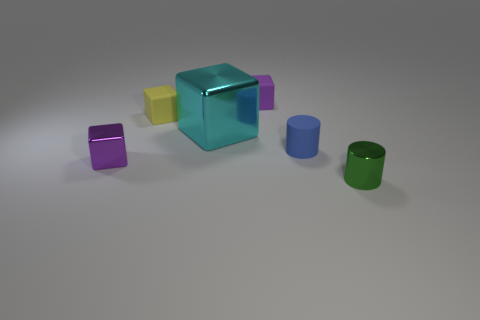What number of other metal cubes are the same color as the big metallic block?
Make the answer very short. 0. What color is the rubber object that is the same shape as the small green shiny thing?
Provide a short and direct response. Blue. What is the shape of the metal thing that is both right of the tiny purple metallic block and behind the shiny cylinder?
Your answer should be very brief. Cube. Is the number of large yellow shiny objects greater than the number of small blue rubber things?
Give a very brief answer. No. What is the small blue cylinder made of?
Ensure brevity in your answer.  Rubber. Is there anything else that is the same size as the cyan thing?
Your response must be concise. No. What size is the cyan object that is the same shape as the yellow thing?
Your answer should be very brief. Large. Is there a tiny matte cylinder behind the shiny thing behind the tiny purple shiny cube?
Your answer should be compact. No. What number of other objects are the same shape as the small blue thing?
Your answer should be very brief. 1. Is the number of tiny purple things that are behind the big shiny cube greater than the number of tiny rubber blocks in front of the blue object?
Make the answer very short. Yes. 